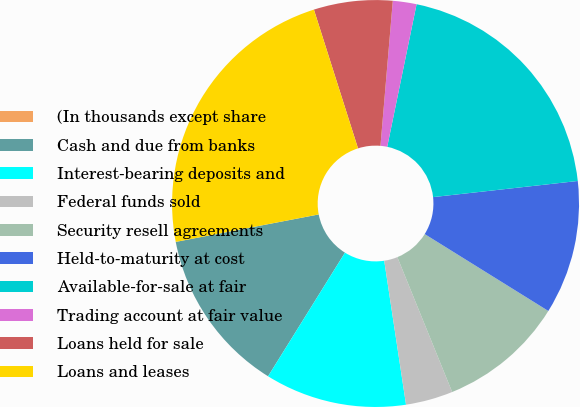<chart> <loc_0><loc_0><loc_500><loc_500><pie_chart><fcel>(In thousands except share<fcel>Cash and due from banks<fcel>Interest-bearing deposits and<fcel>Federal funds sold<fcel>Security resell agreements<fcel>Held-to-maturity at cost<fcel>Available-for-sale at fair<fcel>Trading account at fair value<fcel>Loans held for sale<fcel>Loans and leases<nl><fcel>0.0%<fcel>13.12%<fcel>11.25%<fcel>3.75%<fcel>10.0%<fcel>10.62%<fcel>20.0%<fcel>1.88%<fcel>6.25%<fcel>23.12%<nl></chart> 